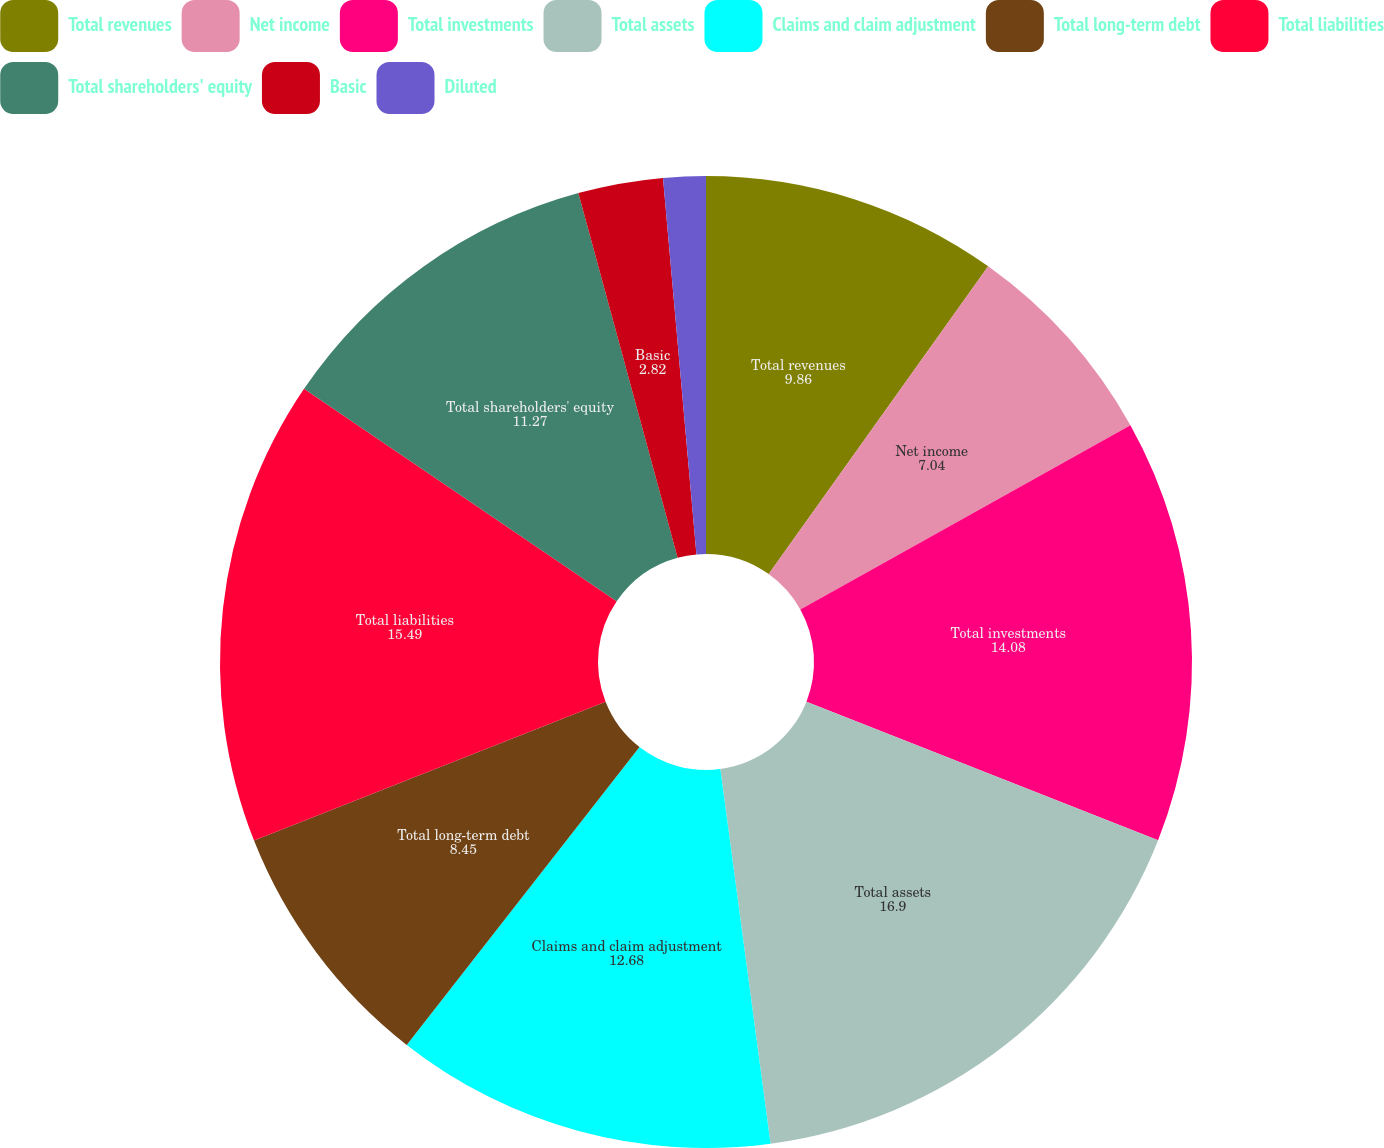Convert chart. <chart><loc_0><loc_0><loc_500><loc_500><pie_chart><fcel>Total revenues<fcel>Net income<fcel>Total investments<fcel>Total assets<fcel>Claims and claim adjustment<fcel>Total long-term debt<fcel>Total liabilities<fcel>Total shareholders' equity<fcel>Basic<fcel>Diluted<nl><fcel>9.86%<fcel>7.04%<fcel>14.08%<fcel>16.9%<fcel>12.68%<fcel>8.45%<fcel>15.49%<fcel>11.27%<fcel>2.82%<fcel>1.41%<nl></chart> 